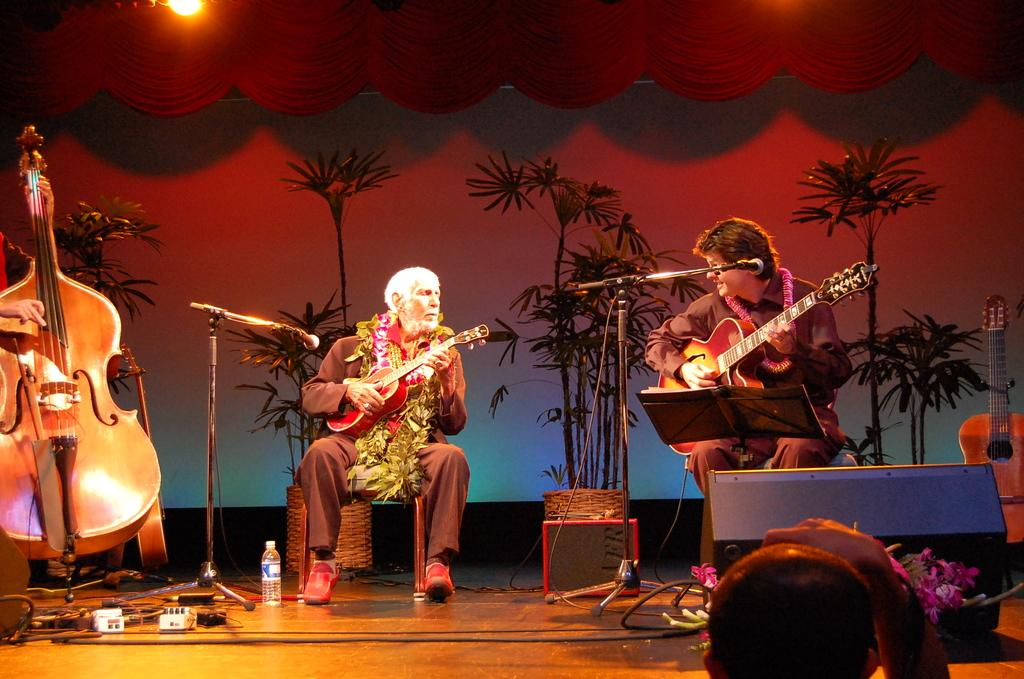How many people are in the image? There are three persons in the image. What are two of the persons doing in the image? Two of them are sitting. What are all three persons holding in the image? They are all holding instruments. Where are they located in the image? They are on a stage. What can be seen in the background of the image? There are plants and a curtain in the background of the image. What type of snake can be seen slithering across the stage in the image? There is no snake present in the image; it features three persons holding instruments on a stage. How many fingers does the person on the left have on their right hand in the image? We cannot determine the number of fingers on the person's right hand from the image alone, as it does not provide a clear view of their hand. 